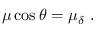Convert formula to latex. <formula><loc_0><loc_0><loc_500><loc_500>\mu \cos \theta = \mu _ { \delta } \ .</formula> 